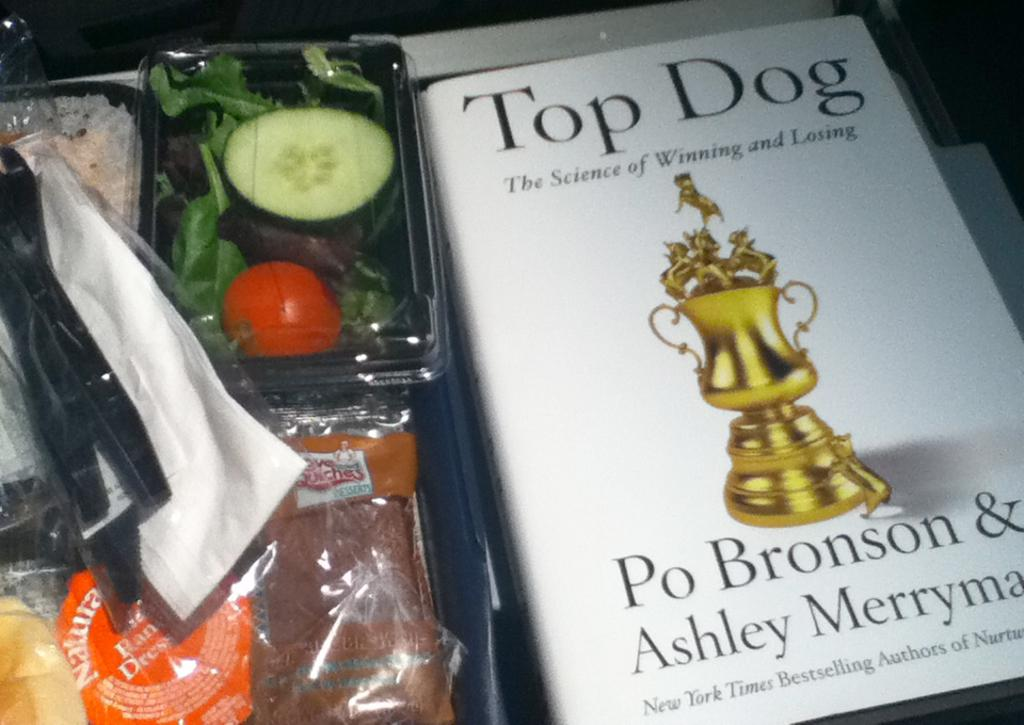Provide a one-sentence caption for the provided image. A to go lunch and a book called Top Dog (The Science of Winning and Losing) written by Po Bronson & Ashley Merryman. 